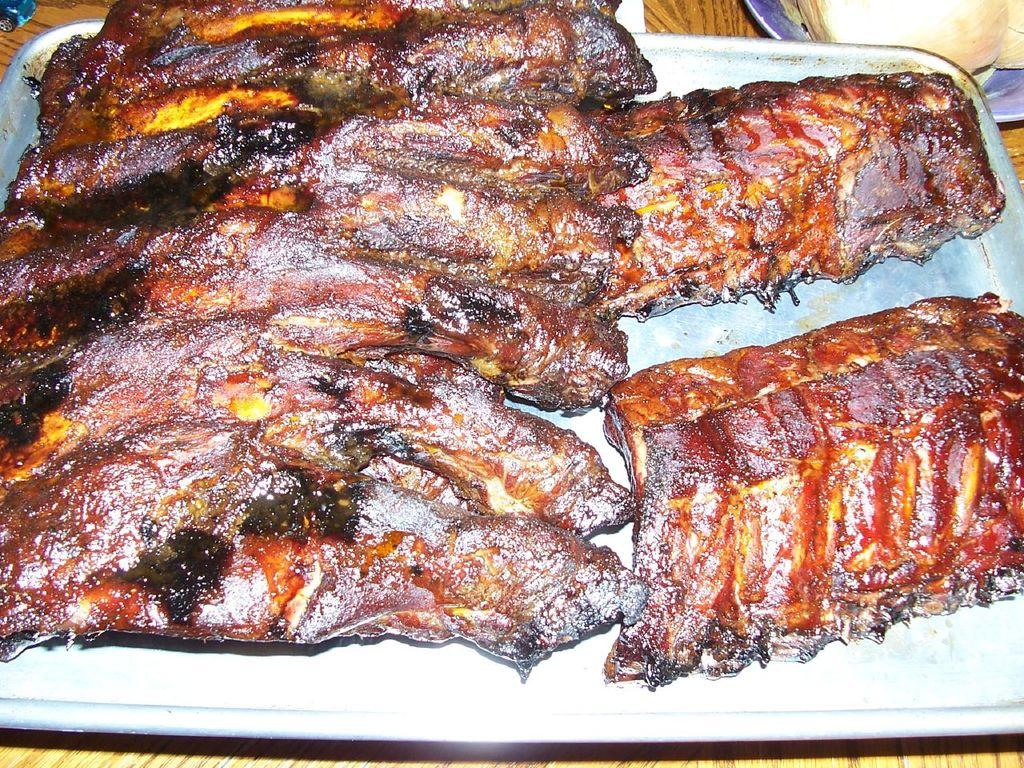What is present on the plate in the image? There are food items in a plate in the image. What can be seen in the background of the image? There is a table in the background of the image. What type of jeans is the man wearing in the image? There is no man present in the image, so it is not possible to determine what type of jeans he might be wearing. 